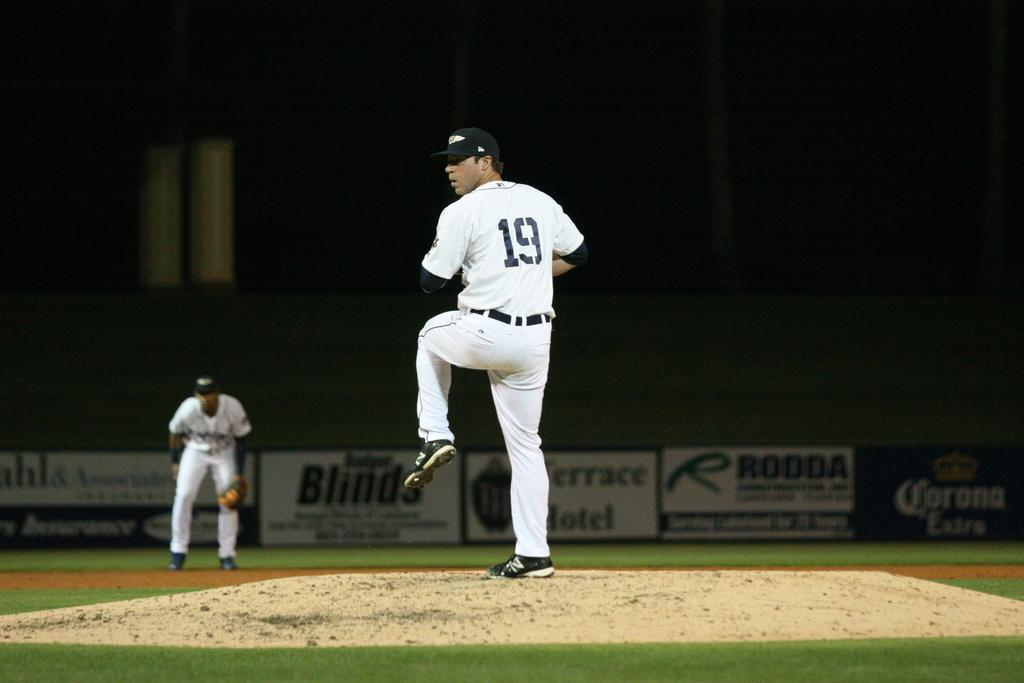<image>
Present a compact description of the photo's key features. Player 19 is about to pitch the ball to the other team. 